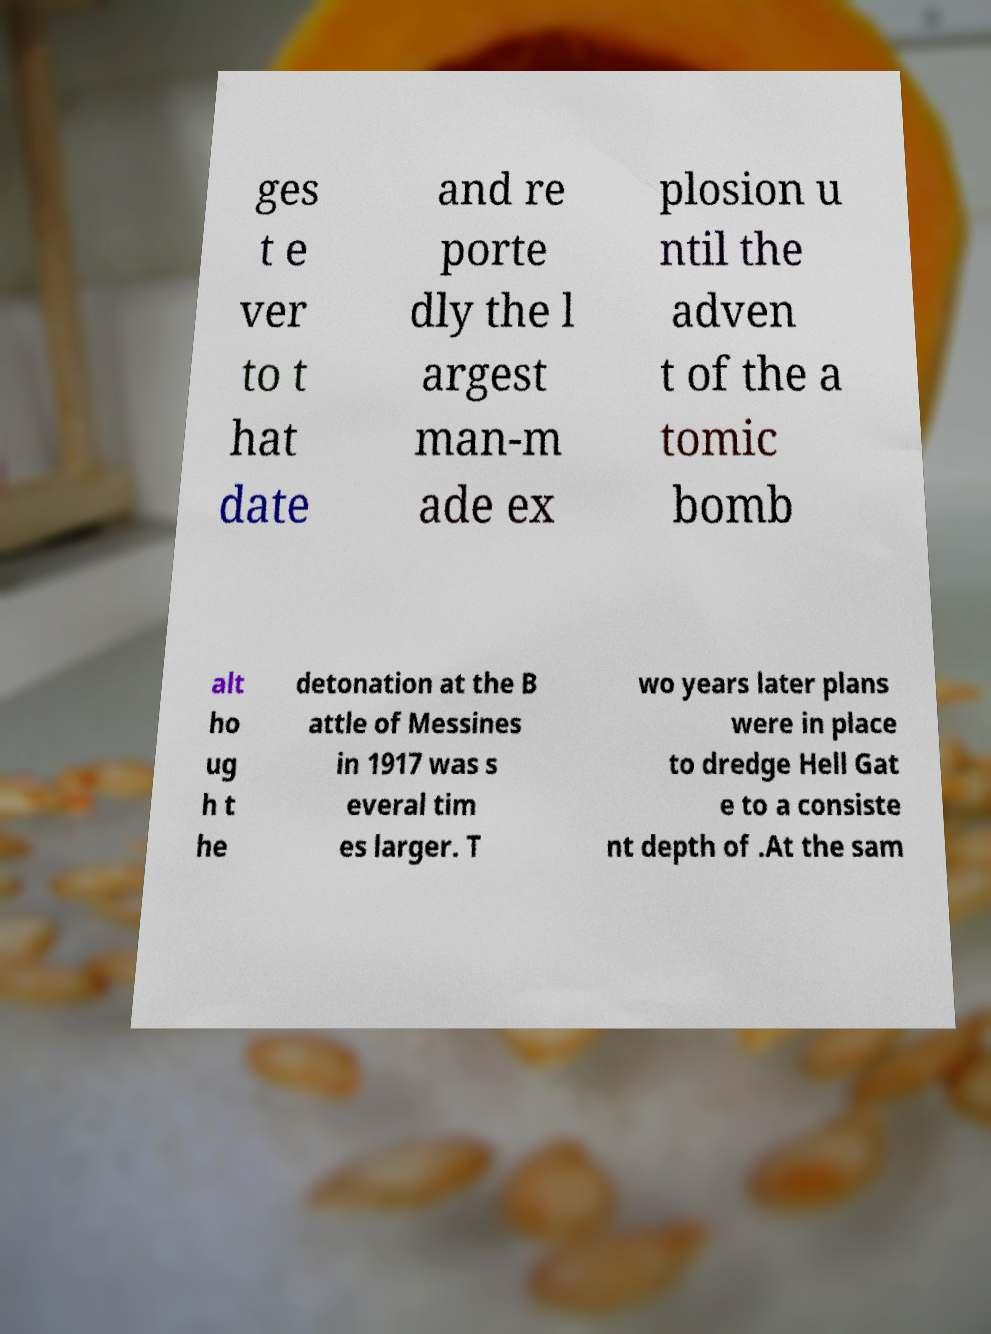Please identify and transcribe the text found in this image. ges t e ver to t hat date and re porte dly the l argest man-m ade ex plosion u ntil the adven t of the a tomic bomb alt ho ug h t he detonation at the B attle of Messines in 1917 was s everal tim es larger. T wo years later plans were in place to dredge Hell Gat e to a consiste nt depth of .At the sam 